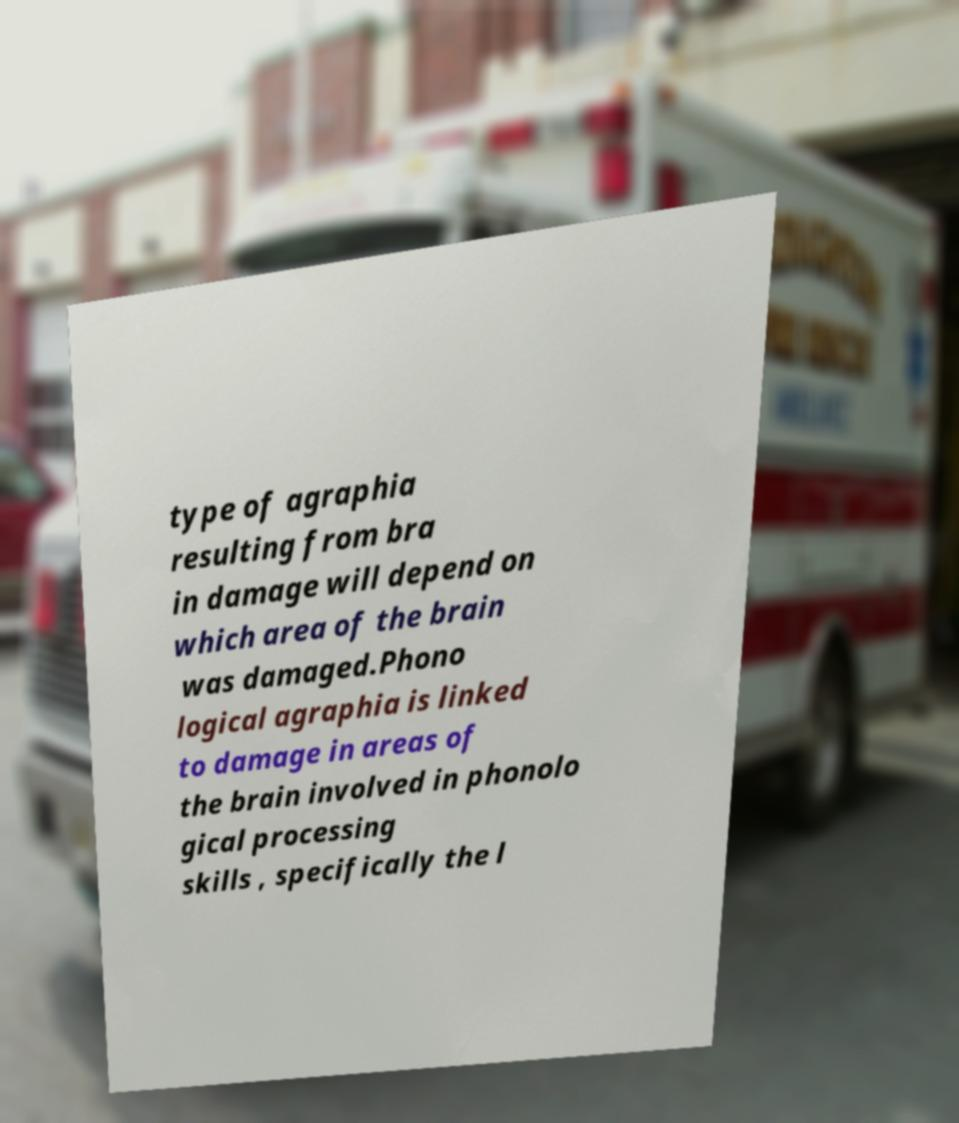Please read and relay the text visible in this image. What does it say? type of agraphia resulting from bra in damage will depend on which area of the brain was damaged.Phono logical agraphia is linked to damage in areas of the brain involved in phonolo gical processing skills , specifically the l 